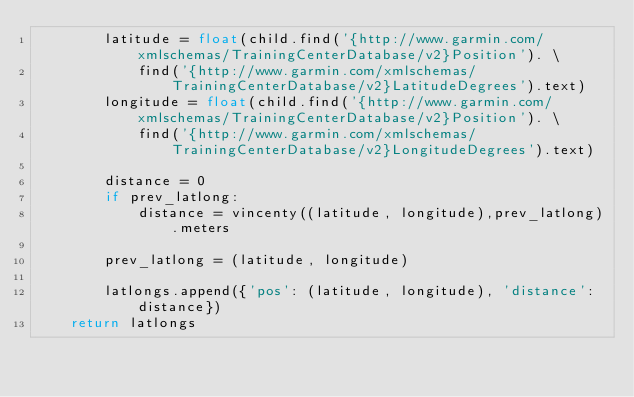<code> <loc_0><loc_0><loc_500><loc_500><_Python_>        latitude = float(child.find('{http://www.garmin.com/xmlschemas/TrainingCenterDatabase/v2}Position'). \
            find('{http://www.garmin.com/xmlschemas/TrainingCenterDatabase/v2}LatitudeDegrees').text)
        longitude = float(child.find('{http://www.garmin.com/xmlschemas/TrainingCenterDatabase/v2}Position'). \
            find('{http://www.garmin.com/xmlschemas/TrainingCenterDatabase/v2}LongitudeDegrees').text)
        
        distance = 0
        if prev_latlong:
            distance = vincenty((latitude, longitude),prev_latlong).meters
            
        prev_latlong = (latitude, longitude)

        latlongs.append({'pos': (latitude, longitude), 'distance': distance})
    return latlongs
</code> 